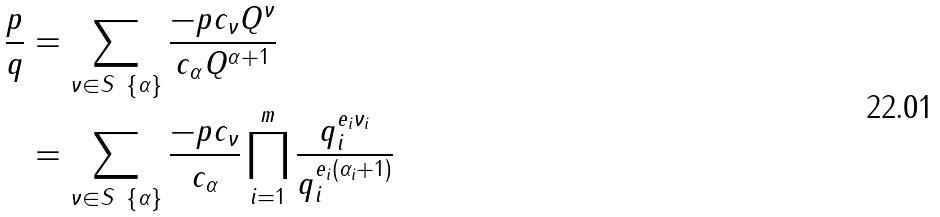<formula> <loc_0><loc_0><loc_500><loc_500>\frac { p } { q } & = \sum _ { \nu \in S \ { \{ \alpha \} } } \frac { - p c _ { \nu } Q ^ { \nu } } { c _ { \alpha } Q ^ { \alpha + 1 } } \\ & = \sum _ { \nu \in S \ { \{ \alpha \} } } \frac { - p c _ { \nu } } { c _ { \alpha } } \prod _ { i = 1 } ^ { m } \frac { q _ { i } ^ { e _ { i } \nu _ { i } } } { q _ { i } ^ { e _ { i } ( \alpha _ { i } + 1 ) } } \\</formula> 